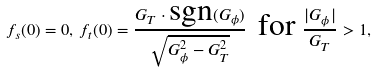<formula> <loc_0><loc_0><loc_500><loc_500>f _ { s } ( 0 ) = 0 , \, f _ { t } ( 0 ) = \frac { G _ { T } \cdot \text {sgn} ( G _ { \phi } ) } { \sqrt { G _ { \phi } ^ { 2 } - G _ { T } ^ { 2 } } } \, \text { for } \frac { | G _ { \phi } | } { G _ { T } } > 1 ,</formula> 